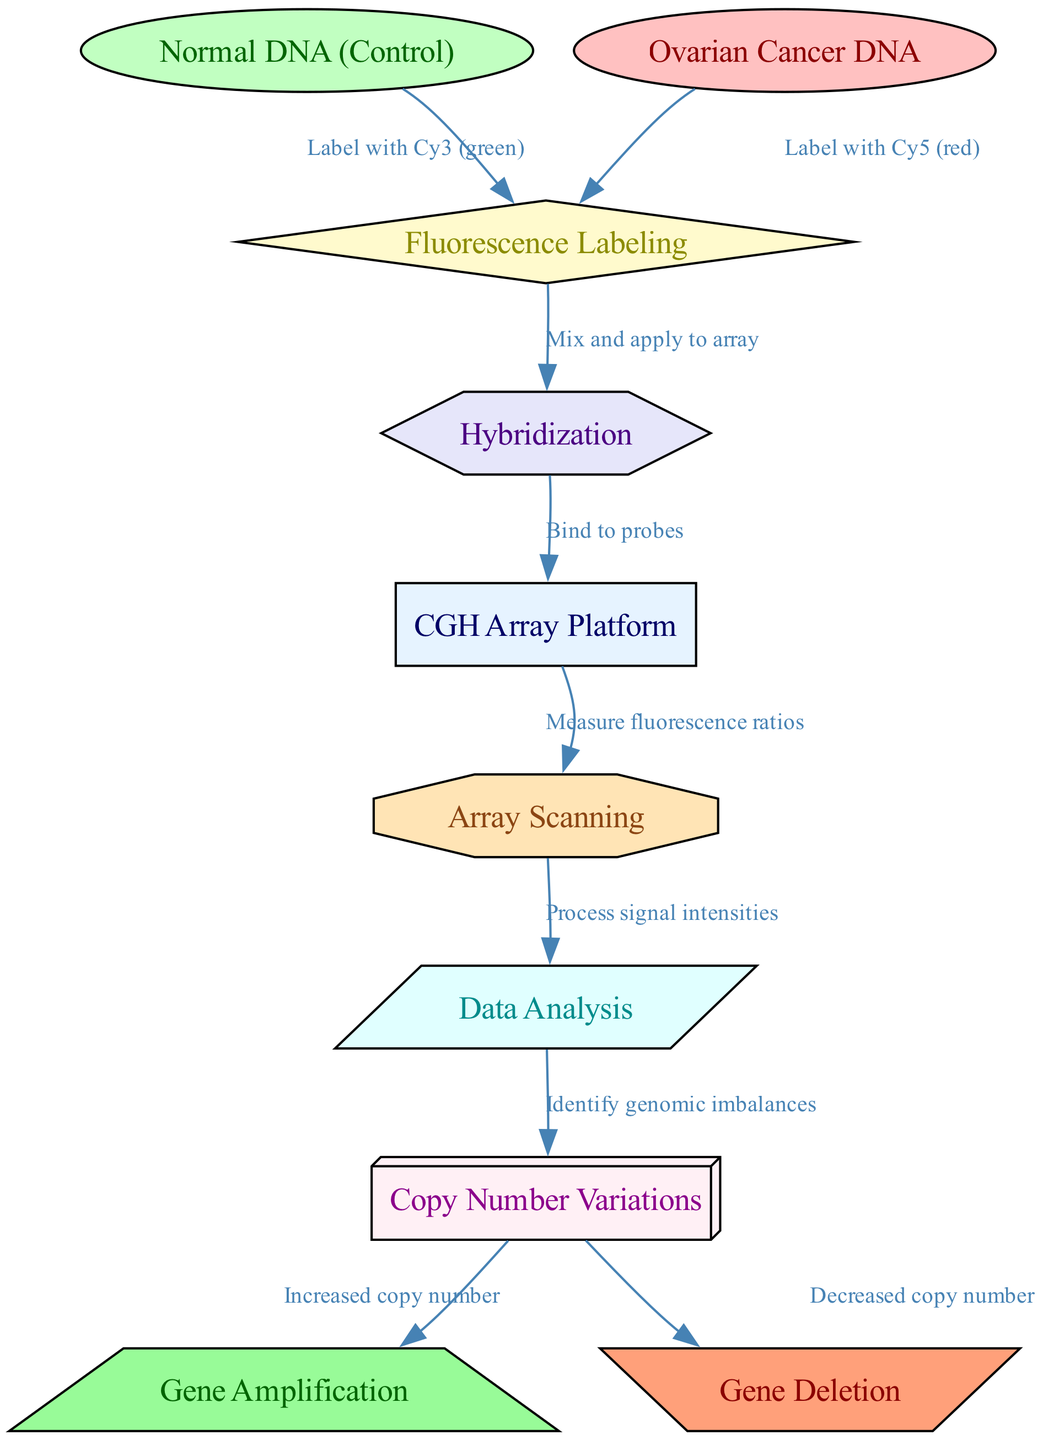What is the initial reference used in the CGH array? The CGH array compares the ovarian cancer DNA against normal DNA, which serves as the control reference in this study. The diagram specifically identifies this as "Normal DNA (Control)".
Answer: Normal DNA (Control) What color represents the tumor DNA in the fluorescence labeling process? In the fluorescence labeling process depicted in the diagram, tumor DNA is labeled with Cy5, which is indicated by the color red.
Answer: Red How many main processes are illustrated in the diagram? The diagram outlines several distinct processes: fluorescence labeling, hybridization, array scanning, and data analysis. Therefore, there are four main processes depicted in this flow.
Answer: Four What type of variations are identified in the analysis phase? The analysis phase identifies genomic imbalances known as "Copy Number Variations", which is a key focus in studying genetic factors in ovarian cancer.
Answer: Copy Number Variations What are the two possible outcomes of copy number variations depicted in the diagram? The diagram indicates two results from copy number variations: increased copy number, which refers to gene amplification, and decreased copy number, which refers to gene deletion.
Answer: Gene Amplification and Gene Deletion How does hybridization relate to the CGH array? The hybridization phase involves binding the labeled DNA samples to the probes on the CGH array, forming an essential step in detecting genomic alterations, as depicted by the connection from hybridization to CGH array in the diagram.
Answer: Bind to probes What step follows the scanning phase in the CGH array process? After the scanning phase, the signal intensities measured are processed during the analysis phase, which is crucial for interpreting the results of the hybridization and identifying genomic changes.
Answer: Data Analysis What is measured during the scanning process of the CGH array? During the scanning process, the fluorescence ratios are measured, which help to determine the levels of DNA from both normal and tumor cells, enabling the detection of genomic imbalances.
Answer: Measure fluorescence ratios 